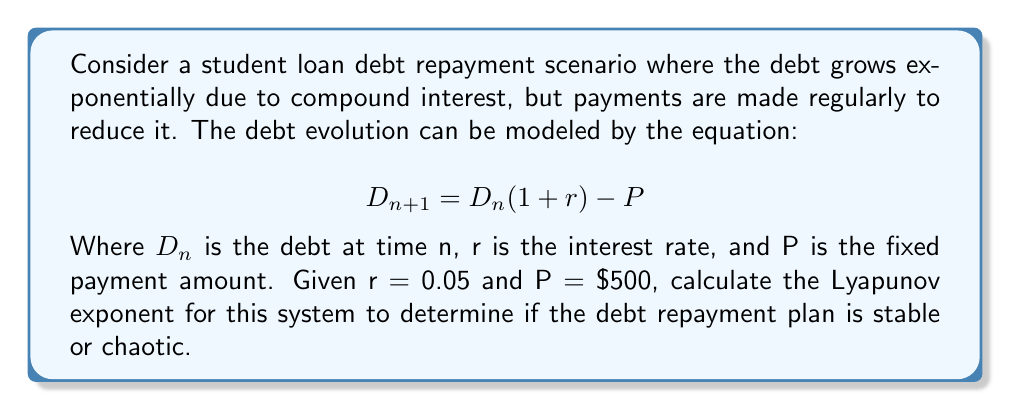What is the answer to this math problem? To calculate the Lyapunov exponent for this debt repayment scenario, we'll follow these steps:

1) The Lyapunov exponent (λ) for a 1-dimensional map is given by:

   $$λ = \lim_{N→∞} \frac{1}{N} \sum_{n=0}^{N-1} \ln|f'(x_n)|$$

   Where f'(x) is the derivative of the map function.

2) In our case, the map function is:

   $$f(D) = D(1+r) - P$$

3) The derivative of this function is:

   $$f'(D) = 1 + r = 1.05$$

4) Since f'(D) is constant, the Lyapunov exponent simplifies to:

   $$λ = \ln|1.05|$$

5) Calculating this value:

   $$λ = \ln(1.05) ≈ 0.0488$$

6) Interpreting the result:
   - A positive Lyapunov exponent indicates chaotic behavior.
   - A negative Lyapunov exponent indicates stable behavior.
   - A zero Lyapunov exponent indicates marginally stable behavior.

In this case, λ > 0, which suggests that the debt repayment scenario is chaotic. This means that small changes in initial conditions (like starting debt amount) can lead to significantly different outcomes over time, making long-term predictions difficult.
Answer: $λ ≈ 0.0488$ (positive, indicating chaotic behavior) 